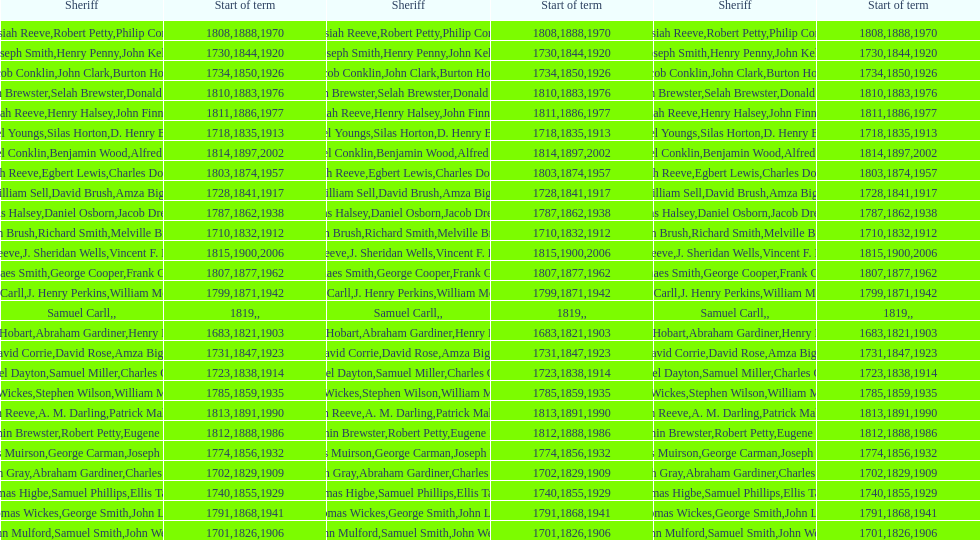What is the total number of sheriffs that were in office in suffolk county between 1903 and 1957? 17. 